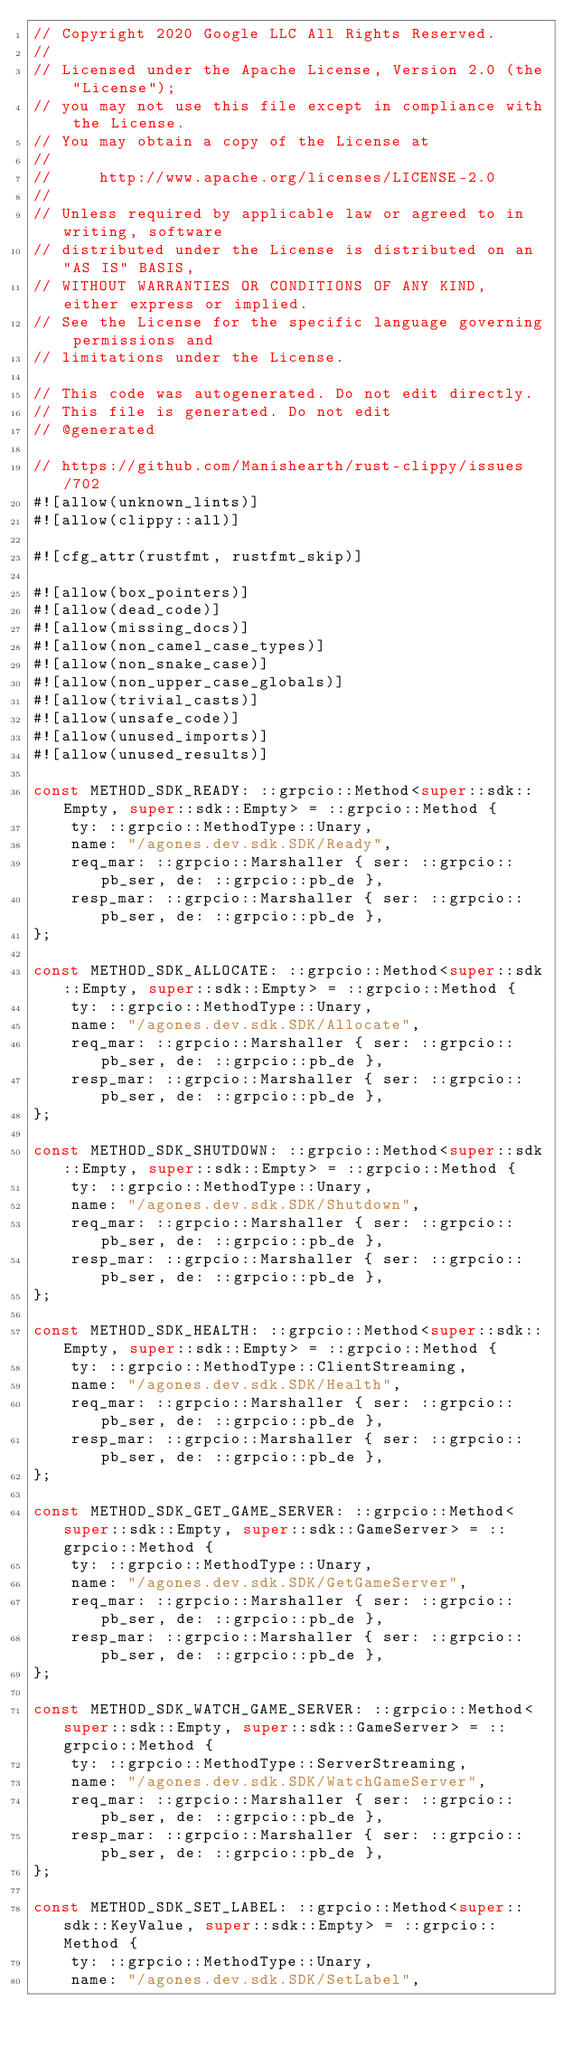<code> <loc_0><loc_0><loc_500><loc_500><_Rust_>// Copyright 2020 Google LLC All Rights Reserved.
//
// Licensed under the Apache License, Version 2.0 (the "License");
// you may not use this file except in compliance with the License.
// You may obtain a copy of the License at
//
//     http://www.apache.org/licenses/LICENSE-2.0
//
// Unless required by applicable law or agreed to in writing, software
// distributed under the License is distributed on an "AS IS" BASIS,
// WITHOUT WARRANTIES OR CONDITIONS OF ANY KIND, either express or implied.
// See the License for the specific language governing permissions and
// limitations under the License.

// This code was autogenerated. Do not edit directly.
// This file is generated. Do not edit
// @generated

// https://github.com/Manishearth/rust-clippy/issues/702
#![allow(unknown_lints)]
#![allow(clippy::all)]

#![cfg_attr(rustfmt, rustfmt_skip)]

#![allow(box_pointers)]
#![allow(dead_code)]
#![allow(missing_docs)]
#![allow(non_camel_case_types)]
#![allow(non_snake_case)]
#![allow(non_upper_case_globals)]
#![allow(trivial_casts)]
#![allow(unsafe_code)]
#![allow(unused_imports)]
#![allow(unused_results)]

const METHOD_SDK_READY: ::grpcio::Method<super::sdk::Empty, super::sdk::Empty> = ::grpcio::Method {
    ty: ::grpcio::MethodType::Unary,
    name: "/agones.dev.sdk.SDK/Ready",
    req_mar: ::grpcio::Marshaller { ser: ::grpcio::pb_ser, de: ::grpcio::pb_de },
    resp_mar: ::grpcio::Marshaller { ser: ::grpcio::pb_ser, de: ::grpcio::pb_de },
};

const METHOD_SDK_ALLOCATE: ::grpcio::Method<super::sdk::Empty, super::sdk::Empty> = ::grpcio::Method {
    ty: ::grpcio::MethodType::Unary,
    name: "/agones.dev.sdk.SDK/Allocate",
    req_mar: ::grpcio::Marshaller { ser: ::grpcio::pb_ser, de: ::grpcio::pb_de },
    resp_mar: ::grpcio::Marshaller { ser: ::grpcio::pb_ser, de: ::grpcio::pb_de },
};

const METHOD_SDK_SHUTDOWN: ::grpcio::Method<super::sdk::Empty, super::sdk::Empty> = ::grpcio::Method {
    ty: ::grpcio::MethodType::Unary,
    name: "/agones.dev.sdk.SDK/Shutdown",
    req_mar: ::grpcio::Marshaller { ser: ::grpcio::pb_ser, de: ::grpcio::pb_de },
    resp_mar: ::grpcio::Marshaller { ser: ::grpcio::pb_ser, de: ::grpcio::pb_de },
};

const METHOD_SDK_HEALTH: ::grpcio::Method<super::sdk::Empty, super::sdk::Empty> = ::grpcio::Method {
    ty: ::grpcio::MethodType::ClientStreaming,
    name: "/agones.dev.sdk.SDK/Health",
    req_mar: ::grpcio::Marshaller { ser: ::grpcio::pb_ser, de: ::grpcio::pb_de },
    resp_mar: ::grpcio::Marshaller { ser: ::grpcio::pb_ser, de: ::grpcio::pb_de },
};

const METHOD_SDK_GET_GAME_SERVER: ::grpcio::Method<super::sdk::Empty, super::sdk::GameServer> = ::grpcio::Method {
    ty: ::grpcio::MethodType::Unary,
    name: "/agones.dev.sdk.SDK/GetGameServer",
    req_mar: ::grpcio::Marshaller { ser: ::grpcio::pb_ser, de: ::grpcio::pb_de },
    resp_mar: ::grpcio::Marshaller { ser: ::grpcio::pb_ser, de: ::grpcio::pb_de },
};

const METHOD_SDK_WATCH_GAME_SERVER: ::grpcio::Method<super::sdk::Empty, super::sdk::GameServer> = ::grpcio::Method {
    ty: ::grpcio::MethodType::ServerStreaming,
    name: "/agones.dev.sdk.SDK/WatchGameServer",
    req_mar: ::grpcio::Marshaller { ser: ::grpcio::pb_ser, de: ::grpcio::pb_de },
    resp_mar: ::grpcio::Marshaller { ser: ::grpcio::pb_ser, de: ::grpcio::pb_de },
};

const METHOD_SDK_SET_LABEL: ::grpcio::Method<super::sdk::KeyValue, super::sdk::Empty> = ::grpcio::Method {
    ty: ::grpcio::MethodType::Unary,
    name: "/agones.dev.sdk.SDK/SetLabel",</code> 